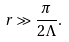<formula> <loc_0><loc_0><loc_500><loc_500>r \gg \frac { \pi } { 2 \Lambda } .</formula> 